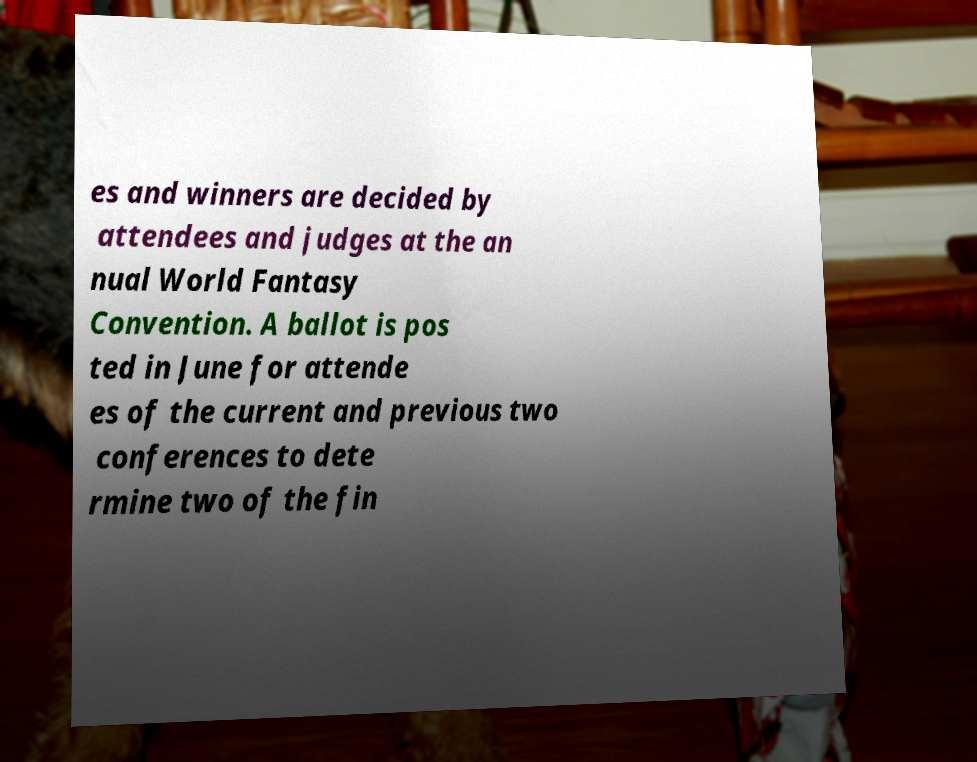What messages or text are displayed in this image? I need them in a readable, typed format. es and winners are decided by attendees and judges at the an nual World Fantasy Convention. A ballot is pos ted in June for attende es of the current and previous two conferences to dete rmine two of the fin 